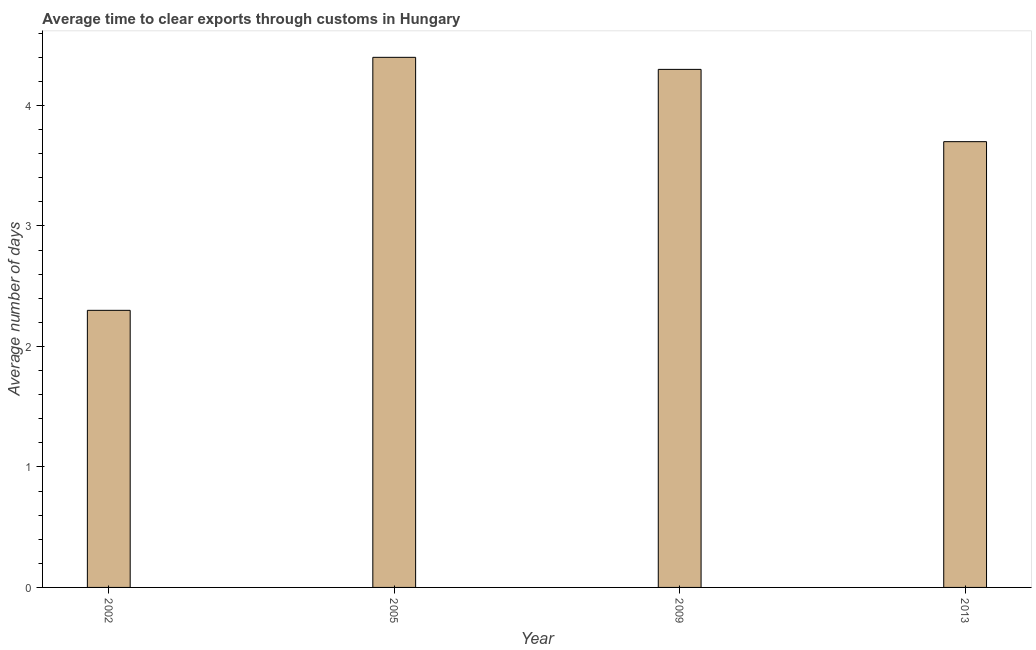Does the graph contain grids?
Give a very brief answer. No. What is the title of the graph?
Ensure brevity in your answer.  Average time to clear exports through customs in Hungary. What is the label or title of the X-axis?
Your response must be concise. Year. What is the label or title of the Y-axis?
Provide a succinct answer. Average number of days. What is the time to clear exports through customs in 2013?
Your answer should be very brief. 3.7. Across all years, what is the minimum time to clear exports through customs?
Keep it short and to the point. 2.3. In which year was the time to clear exports through customs maximum?
Keep it short and to the point. 2005. What is the average time to clear exports through customs per year?
Offer a very short reply. 3.67. Do a majority of the years between 2002 and 2009 (inclusive) have time to clear exports through customs greater than 0.8 days?
Provide a succinct answer. Yes. Is the time to clear exports through customs in 2002 less than that in 2005?
Your response must be concise. Yes. Is the difference between the time to clear exports through customs in 2002 and 2013 greater than the difference between any two years?
Ensure brevity in your answer.  No. What is the difference between the highest and the lowest time to clear exports through customs?
Ensure brevity in your answer.  2.1. In how many years, is the time to clear exports through customs greater than the average time to clear exports through customs taken over all years?
Your answer should be compact. 3. How many years are there in the graph?
Give a very brief answer. 4. What is the Average number of days of 2002?
Your answer should be compact. 2.3. What is the Average number of days in 2009?
Your response must be concise. 4.3. What is the Average number of days in 2013?
Keep it short and to the point. 3.7. What is the difference between the Average number of days in 2002 and 2005?
Make the answer very short. -2.1. What is the difference between the Average number of days in 2009 and 2013?
Make the answer very short. 0.6. What is the ratio of the Average number of days in 2002 to that in 2005?
Your answer should be compact. 0.52. What is the ratio of the Average number of days in 2002 to that in 2009?
Provide a succinct answer. 0.54. What is the ratio of the Average number of days in 2002 to that in 2013?
Provide a succinct answer. 0.62. What is the ratio of the Average number of days in 2005 to that in 2009?
Ensure brevity in your answer.  1.02. What is the ratio of the Average number of days in 2005 to that in 2013?
Make the answer very short. 1.19. What is the ratio of the Average number of days in 2009 to that in 2013?
Your response must be concise. 1.16. 